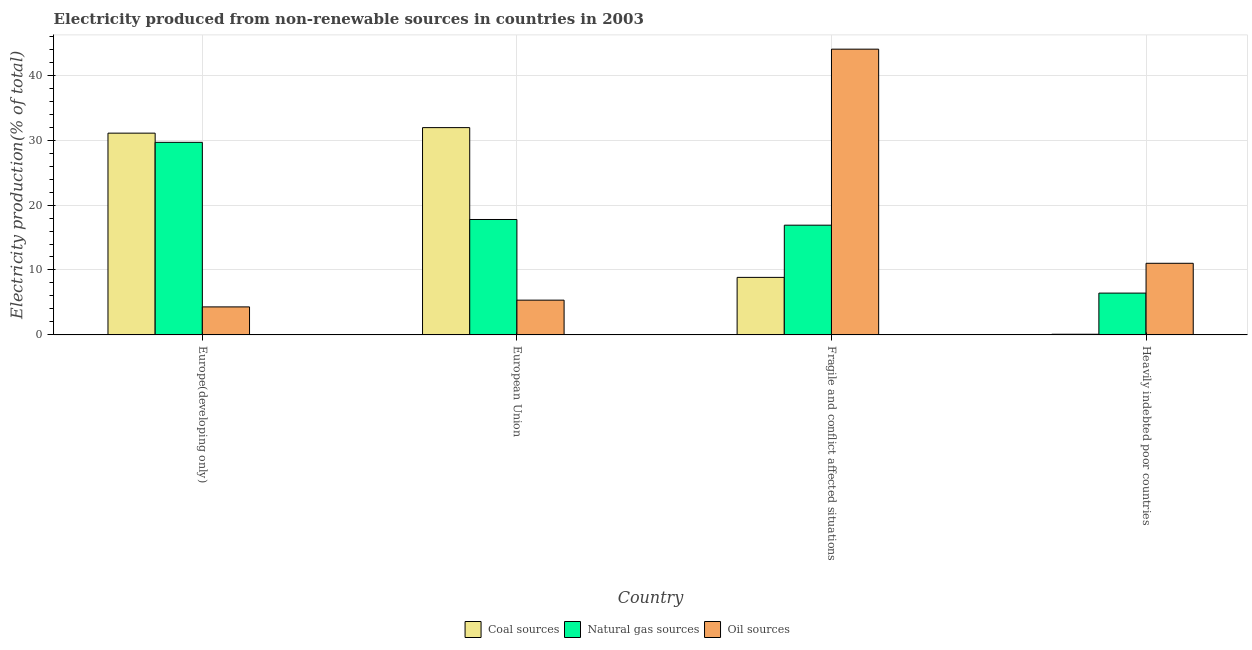How many groups of bars are there?
Your answer should be compact. 4. Are the number of bars per tick equal to the number of legend labels?
Offer a terse response. Yes. How many bars are there on the 2nd tick from the right?
Your response must be concise. 3. What is the label of the 3rd group of bars from the left?
Give a very brief answer. Fragile and conflict affected situations. What is the percentage of electricity produced by natural gas in Europe(developing only)?
Ensure brevity in your answer.  29.66. Across all countries, what is the maximum percentage of electricity produced by coal?
Your answer should be very brief. 31.92. Across all countries, what is the minimum percentage of electricity produced by coal?
Provide a short and direct response. 0.1. In which country was the percentage of electricity produced by oil sources maximum?
Ensure brevity in your answer.  Fragile and conflict affected situations. In which country was the percentage of electricity produced by oil sources minimum?
Offer a terse response. Europe(developing only). What is the total percentage of electricity produced by oil sources in the graph?
Your answer should be compact. 64.7. What is the difference between the percentage of electricity produced by natural gas in European Union and that in Fragile and conflict affected situations?
Provide a short and direct response. 0.88. What is the difference between the percentage of electricity produced by natural gas in European Union and the percentage of electricity produced by oil sources in Fragile and conflict affected situations?
Your answer should be very brief. -26.23. What is the average percentage of electricity produced by coal per country?
Your response must be concise. 17.99. What is the difference between the percentage of electricity produced by natural gas and percentage of electricity produced by oil sources in European Union?
Your answer should be compact. 12.42. In how many countries, is the percentage of electricity produced by oil sources greater than 12 %?
Make the answer very short. 1. What is the ratio of the percentage of electricity produced by oil sources in Fragile and conflict affected situations to that in Heavily indebted poor countries?
Provide a succinct answer. 3.99. Is the percentage of electricity produced by coal in European Union less than that in Heavily indebted poor countries?
Your response must be concise. No. Is the difference between the percentage of electricity produced by coal in Europe(developing only) and Heavily indebted poor countries greater than the difference between the percentage of electricity produced by oil sources in Europe(developing only) and Heavily indebted poor countries?
Your answer should be very brief. Yes. What is the difference between the highest and the second highest percentage of electricity produced by natural gas?
Your response must be concise. 11.88. What is the difference between the highest and the lowest percentage of electricity produced by oil sources?
Offer a terse response. 39.69. What does the 2nd bar from the left in Europe(developing only) represents?
Provide a short and direct response. Natural gas sources. What does the 2nd bar from the right in European Union represents?
Provide a short and direct response. Natural gas sources. How many countries are there in the graph?
Your answer should be compact. 4. Are the values on the major ticks of Y-axis written in scientific E-notation?
Your response must be concise. No. Does the graph contain any zero values?
Make the answer very short. No. Does the graph contain grids?
Provide a short and direct response. Yes. How are the legend labels stacked?
Your answer should be very brief. Horizontal. What is the title of the graph?
Provide a succinct answer. Electricity produced from non-renewable sources in countries in 2003. What is the label or title of the X-axis?
Your answer should be very brief. Country. What is the label or title of the Y-axis?
Your answer should be compact. Electricity production(% of total). What is the Electricity production(% of total) in Coal sources in Europe(developing only)?
Offer a terse response. 31.07. What is the Electricity production(% of total) in Natural gas sources in Europe(developing only)?
Offer a very short reply. 29.66. What is the Electricity production(% of total) of Oil sources in Europe(developing only)?
Your answer should be compact. 4.31. What is the Electricity production(% of total) of Coal sources in European Union?
Offer a very short reply. 31.92. What is the Electricity production(% of total) in Natural gas sources in European Union?
Your answer should be very brief. 17.78. What is the Electricity production(% of total) of Oil sources in European Union?
Make the answer very short. 5.35. What is the Electricity production(% of total) in Coal sources in Fragile and conflict affected situations?
Offer a terse response. 8.86. What is the Electricity production(% of total) in Natural gas sources in Fragile and conflict affected situations?
Provide a succinct answer. 16.9. What is the Electricity production(% of total) in Oil sources in Fragile and conflict affected situations?
Your answer should be compact. 44.01. What is the Electricity production(% of total) in Coal sources in Heavily indebted poor countries?
Ensure brevity in your answer.  0.1. What is the Electricity production(% of total) in Natural gas sources in Heavily indebted poor countries?
Provide a succinct answer. 6.44. What is the Electricity production(% of total) of Oil sources in Heavily indebted poor countries?
Your answer should be very brief. 11.03. Across all countries, what is the maximum Electricity production(% of total) of Coal sources?
Give a very brief answer. 31.92. Across all countries, what is the maximum Electricity production(% of total) of Natural gas sources?
Keep it short and to the point. 29.66. Across all countries, what is the maximum Electricity production(% of total) of Oil sources?
Your response must be concise. 44.01. Across all countries, what is the minimum Electricity production(% of total) in Coal sources?
Your answer should be very brief. 0.1. Across all countries, what is the minimum Electricity production(% of total) of Natural gas sources?
Keep it short and to the point. 6.44. Across all countries, what is the minimum Electricity production(% of total) of Oil sources?
Your answer should be very brief. 4.31. What is the total Electricity production(% of total) of Coal sources in the graph?
Provide a short and direct response. 71.96. What is the total Electricity production(% of total) of Natural gas sources in the graph?
Your response must be concise. 70.77. What is the total Electricity production(% of total) of Oil sources in the graph?
Ensure brevity in your answer.  64.7. What is the difference between the Electricity production(% of total) of Coal sources in Europe(developing only) and that in European Union?
Offer a terse response. -0.85. What is the difference between the Electricity production(% of total) of Natural gas sources in Europe(developing only) and that in European Union?
Your response must be concise. 11.88. What is the difference between the Electricity production(% of total) in Oil sources in Europe(developing only) and that in European Union?
Ensure brevity in your answer.  -1.04. What is the difference between the Electricity production(% of total) of Coal sources in Europe(developing only) and that in Fragile and conflict affected situations?
Ensure brevity in your answer.  22.21. What is the difference between the Electricity production(% of total) of Natural gas sources in Europe(developing only) and that in Fragile and conflict affected situations?
Ensure brevity in your answer.  12.76. What is the difference between the Electricity production(% of total) of Oil sources in Europe(developing only) and that in Fragile and conflict affected situations?
Make the answer very short. -39.69. What is the difference between the Electricity production(% of total) of Coal sources in Europe(developing only) and that in Heavily indebted poor countries?
Ensure brevity in your answer.  30.97. What is the difference between the Electricity production(% of total) of Natural gas sources in Europe(developing only) and that in Heavily indebted poor countries?
Offer a very short reply. 23.22. What is the difference between the Electricity production(% of total) of Oil sources in Europe(developing only) and that in Heavily indebted poor countries?
Your response must be concise. -6.72. What is the difference between the Electricity production(% of total) of Coal sources in European Union and that in Fragile and conflict affected situations?
Make the answer very short. 23.06. What is the difference between the Electricity production(% of total) in Natural gas sources in European Union and that in Fragile and conflict affected situations?
Provide a short and direct response. 0.88. What is the difference between the Electricity production(% of total) in Oil sources in European Union and that in Fragile and conflict affected situations?
Keep it short and to the point. -38.65. What is the difference between the Electricity production(% of total) in Coal sources in European Union and that in Heavily indebted poor countries?
Provide a short and direct response. 31.82. What is the difference between the Electricity production(% of total) of Natural gas sources in European Union and that in Heavily indebted poor countries?
Your response must be concise. 11.34. What is the difference between the Electricity production(% of total) in Oil sources in European Union and that in Heavily indebted poor countries?
Offer a very short reply. -5.68. What is the difference between the Electricity production(% of total) in Coal sources in Fragile and conflict affected situations and that in Heavily indebted poor countries?
Keep it short and to the point. 8.76. What is the difference between the Electricity production(% of total) in Natural gas sources in Fragile and conflict affected situations and that in Heavily indebted poor countries?
Your response must be concise. 10.46. What is the difference between the Electricity production(% of total) of Oil sources in Fragile and conflict affected situations and that in Heavily indebted poor countries?
Your answer should be very brief. 32.98. What is the difference between the Electricity production(% of total) of Coal sources in Europe(developing only) and the Electricity production(% of total) of Natural gas sources in European Union?
Your answer should be very brief. 13.3. What is the difference between the Electricity production(% of total) of Coal sources in Europe(developing only) and the Electricity production(% of total) of Oil sources in European Union?
Make the answer very short. 25.72. What is the difference between the Electricity production(% of total) of Natural gas sources in Europe(developing only) and the Electricity production(% of total) of Oil sources in European Union?
Provide a succinct answer. 24.3. What is the difference between the Electricity production(% of total) in Coal sources in Europe(developing only) and the Electricity production(% of total) in Natural gas sources in Fragile and conflict affected situations?
Ensure brevity in your answer.  14.17. What is the difference between the Electricity production(% of total) of Coal sources in Europe(developing only) and the Electricity production(% of total) of Oil sources in Fragile and conflict affected situations?
Give a very brief answer. -12.93. What is the difference between the Electricity production(% of total) in Natural gas sources in Europe(developing only) and the Electricity production(% of total) in Oil sources in Fragile and conflict affected situations?
Ensure brevity in your answer.  -14.35. What is the difference between the Electricity production(% of total) in Coal sources in Europe(developing only) and the Electricity production(% of total) in Natural gas sources in Heavily indebted poor countries?
Your answer should be compact. 24.63. What is the difference between the Electricity production(% of total) of Coal sources in Europe(developing only) and the Electricity production(% of total) of Oil sources in Heavily indebted poor countries?
Offer a very short reply. 20.04. What is the difference between the Electricity production(% of total) of Natural gas sources in Europe(developing only) and the Electricity production(% of total) of Oil sources in Heavily indebted poor countries?
Provide a succinct answer. 18.63. What is the difference between the Electricity production(% of total) of Coal sources in European Union and the Electricity production(% of total) of Natural gas sources in Fragile and conflict affected situations?
Make the answer very short. 15.03. What is the difference between the Electricity production(% of total) of Coal sources in European Union and the Electricity production(% of total) of Oil sources in Fragile and conflict affected situations?
Your response must be concise. -12.08. What is the difference between the Electricity production(% of total) in Natural gas sources in European Union and the Electricity production(% of total) in Oil sources in Fragile and conflict affected situations?
Your answer should be compact. -26.23. What is the difference between the Electricity production(% of total) in Coal sources in European Union and the Electricity production(% of total) in Natural gas sources in Heavily indebted poor countries?
Provide a short and direct response. 25.48. What is the difference between the Electricity production(% of total) of Coal sources in European Union and the Electricity production(% of total) of Oil sources in Heavily indebted poor countries?
Make the answer very short. 20.9. What is the difference between the Electricity production(% of total) in Natural gas sources in European Union and the Electricity production(% of total) in Oil sources in Heavily indebted poor countries?
Ensure brevity in your answer.  6.75. What is the difference between the Electricity production(% of total) in Coal sources in Fragile and conflict affected situations and the Electricity production(% of total) in Natural gas sources in Heavily indebted poor countries?
Offer a terse response. 2.42. What is the difference between the Electricity production(% of total) in Coal sources in Fragile and conflict affected situations and the Electricity production(% of total) in Oil sources in Heavily indebted poor countries?
Your response must be concise. -2.17. What is the difference between the Electricity production(% of total) of Natural gas sources in Fragile and conflict affected situations and the Electricity production(% of total) of Oil sources in Heavily indebted poor countries?
Give a very brief answer. 5.87. What is the average Electricity production(% of total) in Coal sources per country?
Make the answer very short. 17.99. What is the average Electricity production(% of total) in Natural gas sources per country?
Your answer should be compact. 17.69. What is the average Electricity production(% of total) in Oil sources per country?
Give a very brief answer. 16.18. What is the difference between the Electricity production(% of total) of Coal sources and Electricity production(% of total) of Natural gas sources in Europe(developing only)?
Offer a terse response. 1.42. What is the difference between the Electricity production(% of total) of Coal sources and Electricity production(% of total) of Oil sources in Europe(developing only)?
Your answer should be compact. 26.76. What is the difference between the Electricity production(% of total) in Natural gas sources and Electricity production(% of total) in Oil sources in Europe(developing only)?
Offer a very short reply. 25.34. What is the difference between the Electricity production(% of total) of Coal sources and Electricity production(% of total) of Natural gas sources in European Union?
Provide a succinct answer. 14.15. What is the difference between the Electricity production(% of total) in Coal sources and Electricity production(% of total) in Oil sources in European Union?
Provide a succinct answer. 26.57. What is the difference between the Electricity production(% of total) in Natural gas sources and Electricity production(% of total) in Oil sources in European Union?
Your response must be concise. 12.42. What is the difference between the Electricity production(% of total) in Coal sources and Electricity production(% of total) in Natural gas sources in Fragile and conflict affected situations?
Offer a terse response. -8.04. What is the difference between the Electricity production(% of total) of Coal sources and Electricity production(% of total) of Oil sources in Fragile and conflict affected situations?
Provide a succinct answer. -35.15. What is the difference between the Electricity production(% of total) of Natural gas sources and Electricity production(% of total) of Oil sources in Fragile and conflict affected situations?
Offer a terse response. -27.11. What is the difference between the Electricity production(% of total) of Coal sources and Electricity production(% of total) of Natural gas sources in Heavily indebted poor countries?
Give a very brief answer. -6.34. What is the difference between the Electricity production(% of total) of Coal sources and Electricity production(% of total) of Oil sources in Heavily indebted poor countries?
Your response must be concise. -10.93. What is the difference between the Electricity production(% of total) of Natural gas sources and Electricity production(% of total) of Oil sources in Heavily indebted poor countries?
Your answer should be very brief. -4.59. What is the ratio of the Electricity production(% of total) of Coal sources in Europe(developing only) to that in European Union?
Your answer should be compact. 0.97. What is the ratio of the Electricity production(% of total) in Natural gas sources in Europe(developing only) to that in European Union?
Your answer should be compact. 1.67. What is the ratio of the Electricity production(% of total) of Oil sources in Europe(developing only) to that in European Union?
Provide a succinct answer. 0.81. What is the ratio of the Electricity production(% of total) in Coal sources in Europe(developing only) to that in Fragile and conflict affected situations?
Make the answer very short. 3.51. What is the ratio of the Electricity production(% of total) of Natural gas sources in Europe(developing only) to that in Fragile and conflict affected situations?
Provide a succinct answer. 1.75. What is the ratio of the Electricity production(% of total) in Oil sources in Europe(developing only) to that in Fragile and conflict affected situations?
Offer a terse response. 0.1. What is the ratio of the Electricity production(% of total) of Coal sources in Europe(developing only) to that in Heavily indebted poor countries?
Provide a succinct answer. 302.84. What is the ratio of the Electricity production(% of total) in Natural gas sources in Europe(developing only) to that in Heavily indebted poor countries?
Your answer should be very brief. 4.61. What is the ratio of the Electricity production(% of total) of Oil sources in Europe(developing only) to that in Heavily indebted poor countries?
Your answer should be compact. 0.39. What is the ratio of the Electricity production(% of total) in Coal sources in European Union to that in Fragile and conflict affected situations?
Make the answer very short. 3.6. What is the ratio of the Electricity production(% of total) in Natural gas sources in European Union to that in Fragile and conflict affected situations?
Give a very brief answer. 1.05. What is the ratio of the Electricity production(% of total) of Oil sources in European Union to that in Fragile and conflict affected situations?
Make the answer very short. 0.12. What is the ratio of the Electricity production(% of total) in Coal sources in European Union to that in Heavily indebted poor countries?
Keep it short and to the point. 311.14. What is the ratio of the Electricity production(% of total) of Natural gas sources in European Union to that in Heavily indebted poor countries?
Ensure brevity in your answer.  2.76. What is the ratio of the Electricity production(% of total) of Oil sources in European Union to that in Heavily indebted poor countries?
Make the answer very short. 0.49. What is the ratio of the Electricity production(% of total) in Coal sources in Fragile and conflict affected situations to that in Heavily indebted poor countries?
Your response must be concise. 86.35. What is the ratio of the Electricity production(% of total) in Natural gas sources in Fragile and conflict affected situations to that in Heavily indebted poor countries?
Provide a succinct answer. 2.62. What is the ratio of the Electricity production(% of total) of Oil sources in Fragile and conflict affected situations to that in Heavily indebted poor countries?
Offer a terse response. 3.99. What is the difference between the highest and the second highest Electricity production(% of total) of Coal sources?
Ensure brevity in your answer.  0.85. What is the difference between the highest and the second highest Electricity production(% of total) of Natural gas sources?
Offer a terse response. 11.88. What is the difference between the highest and the second highest Electricity production(% of total) of Oil sources?
Your response must be concise. 32.98. What is the difference between the highest and the lowest Electricity production(% of total) of Coal sources?
Your answer should be very brief. 31.82. What is the difference between the highest and the lowest Electricity production(% of total) of Natural gas sources?
Give a very brief answer. 23.22. What is the difference between the highest and the lowest Electricity production(% of total) in Oil sources?
Ensure brevity in your answer.  39.69. 